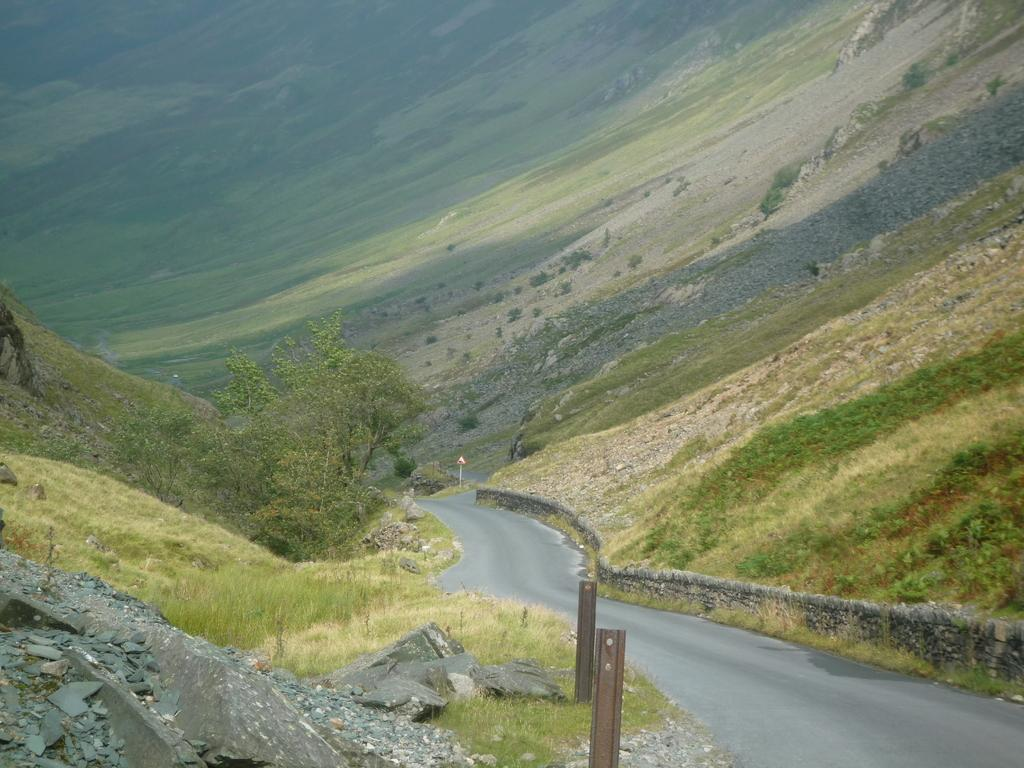What is located in the middle of the image? There is a road in the middle of the image. What can be seen on the right side of the image? There is a wall on the right side of the image. What type of vegetation is present in the image? There is grass and a tree in the image. What materials can be identified in the image? There are metal rods and stones in the image. What is the purpose of the sign board in the image? The purpose of the sign board in the image is to provide information or directions. How far away is the kitty from the tree in the image? There is no kitty present in the image, so it is not possible to determine the distance between a kitty and the tree. 